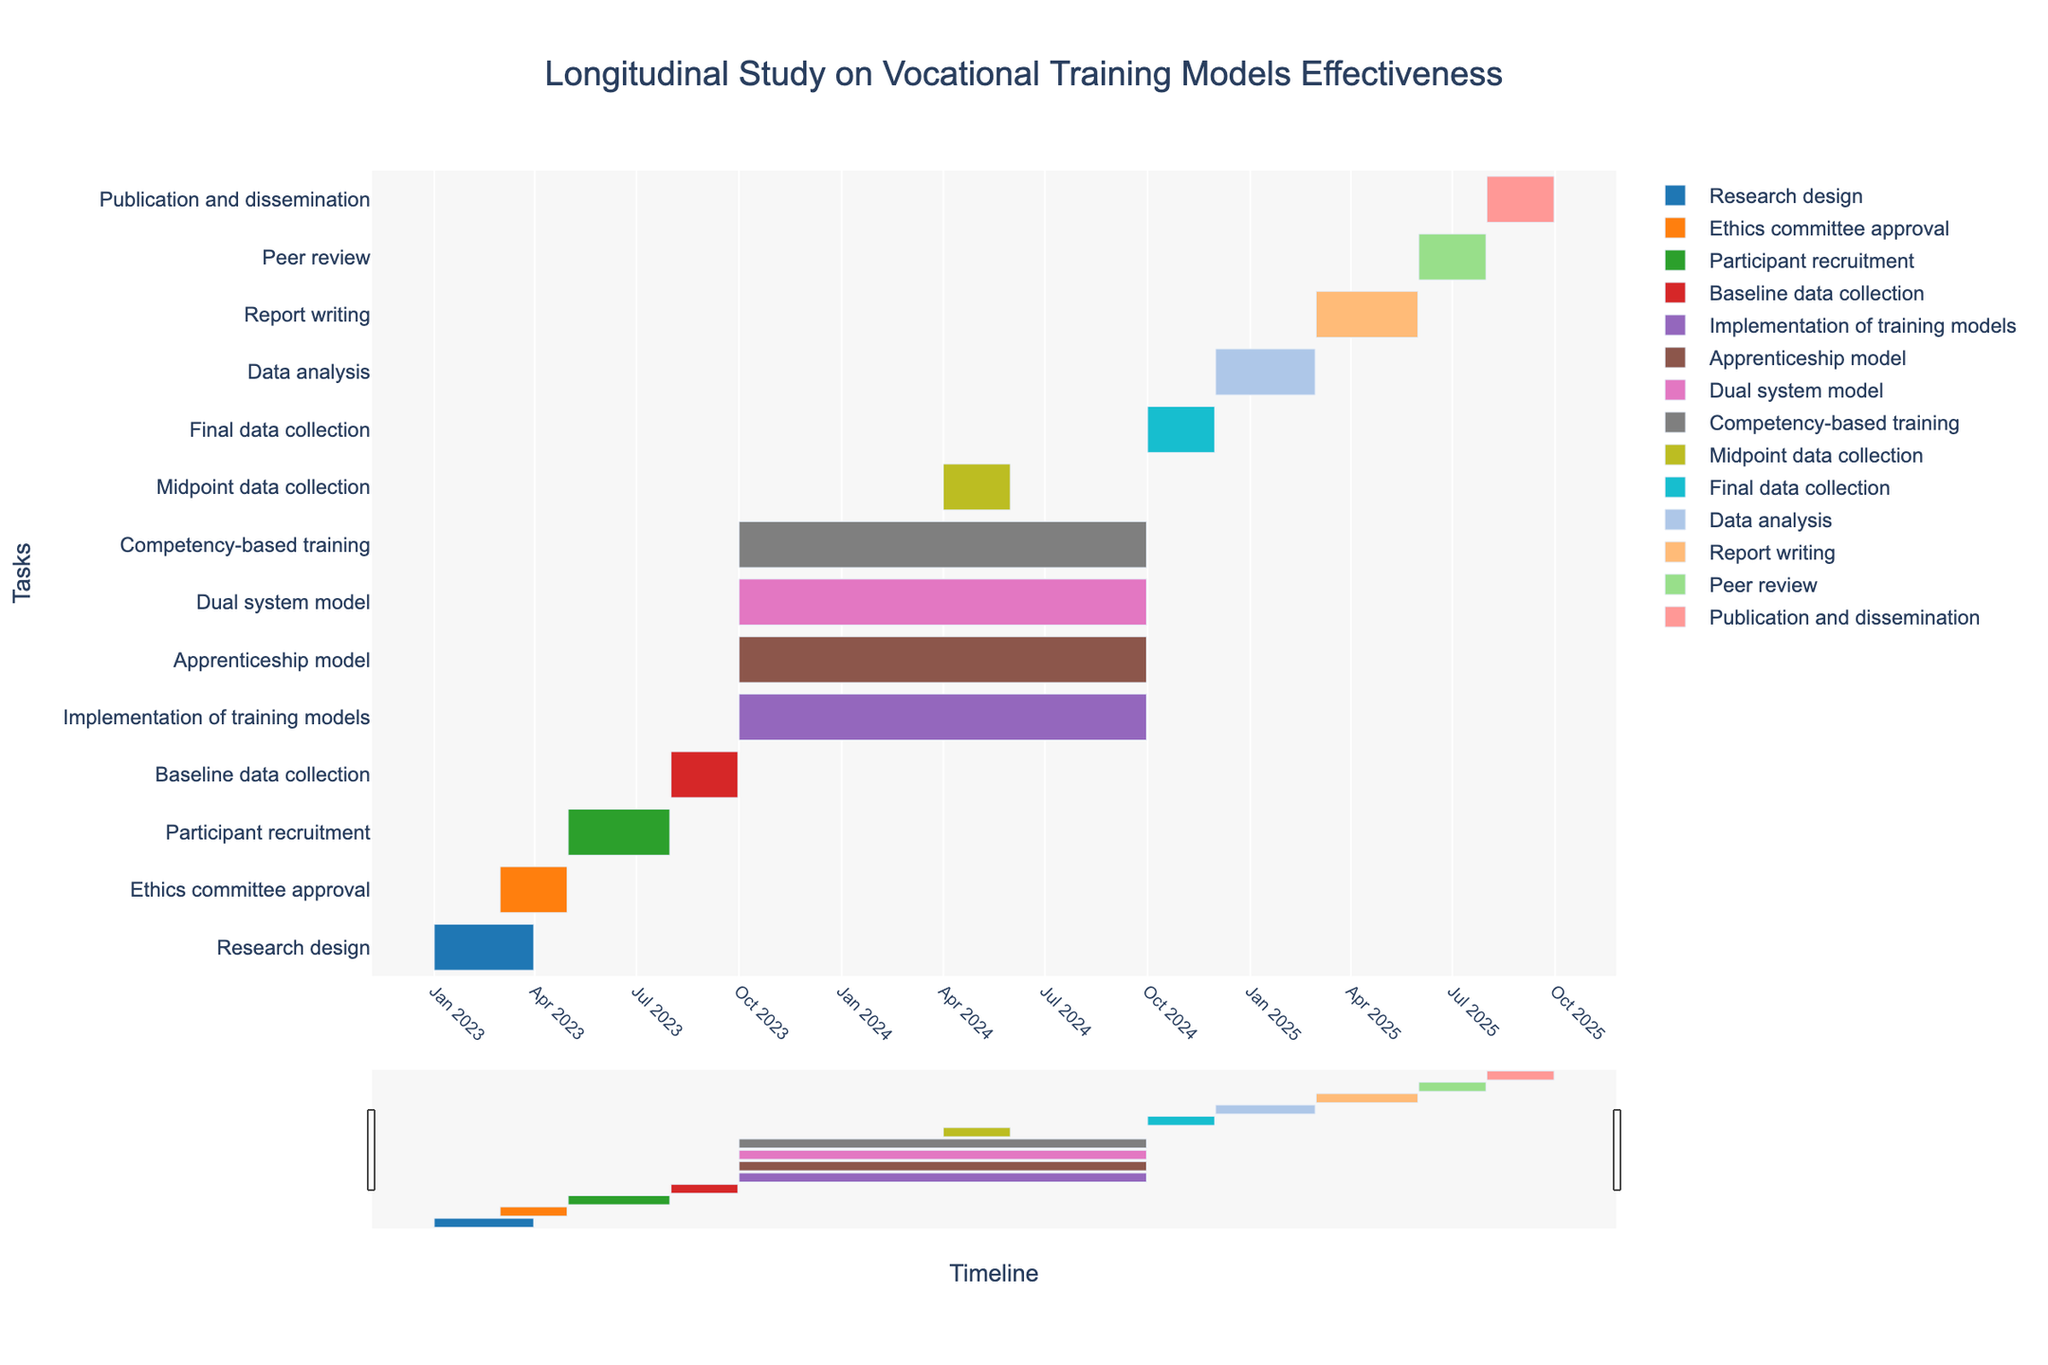What is the title of the Gantt chart? The title of the Gantt chart is located at the top center of the chart, making it the most prominent text element. By reading this text, the title can be identified.
Answer: Longitudinal Study on Vocational Training Models Effectiveness What is the time span for the Ethics committee approval stage? To determine the time span for the Ethics committee approval, locate the respective task in the Gantt chart and note the start and end dates, then calculate the difference. The Ethics committee approval starts in March 2023 and ends in April 2023.
Answer: March 2023 to April 2023 Which stage ends first: Baseline data collection or Participant recruitment? Locate both stages in the chart and compare their end dates. Baseline data collection ends in September 2023, while Participant recruitment ends in July 2023.
Answer: Participant recruitment How long is the implementation period for the training models? Find the Implementation of training models task and note its start and end dates, then calculate the total duration. It begins in October 2023 and ends in September 2024.
Answer: 12 months What are the color representations for the Apprenticeship model and Dual system model tasks? Refer to the color legend on the Gantt chart to identify the specific colors assigned to these tasks. The Apprenticeship model is brown, and the Dual system model is pink.
Answer: Brown for Apprenticeship model and pink for Dual system model Which data collection stage spans the shortest duration? Compare the durations of the Baseline data collection, Midpoint data collection, and Final data collection stages. The Midpoint data collection stage spans only two months, from April to May 2024.
Answer: Midpoint data collection Between the Data analysis and Report writing stages, which one starts first and which lasts longer? Locate both stages and note their start dates and durations. Data analysis starts in December 2024 and lasts for 3 months, while Report writing starts in March 2025 and also lasts for 3 months. Data analysis starts first.
Answer: Data analysis starts first, both last for 3 months What is the timeline for the Peer review stage? Identify the Peer review task on the Gantt chart and check its start and end dates. It starts in June 2025 and ends in July 2025.
Answer: June 2025 to July 2025 Calculate the total duration from the start of Research design to the end of Publication and dissemination? Note the start date of the Research design stage and the end date of the Publication and dissemination stage. Calculate the total duration from January 2023 to September 2025.
Answer: 32 months 